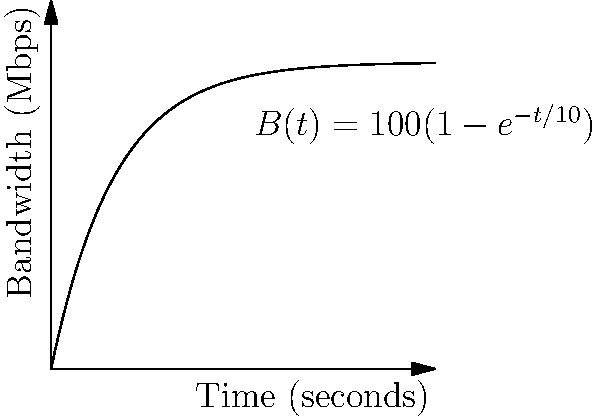Given the network bandwidth curve $B(t) = 100(1-e^{-t/10})$ Mbps, where $t$ is time in seconds, determine the optimal time to transfer a 500 MB file to maximize the average transfer rate. Round your answer to the nearest second. To find the optimal time, we need to maximize the average transfer rate. Let's approach this step-by-step:

1) The total data transferred up to time $t$ is the integral of $B(t)$ from 0 to $t$:

   $D(t) = \int_0^t B(t) dt = \int_0^t 100(1-e^{-t/10}) dt = 100t + 1000e^{-t/10} - 1000$

2) The average transfer rate $R(t)$ is the total data transferred divided by time:

   $R(t) = \frac{D(t)}{t} = 100 + \frac{1000}{t}(e^{-t/10} - 1)$

3) To find the maximum, we differentiate $R(t)$ and set it to zero:

   $R'(t) = \frac{1000}{t^2}(1 - e^{-t/10}(1 + \frac{t}{10})) = 0$

4) This equation can't be solved analytically. We need to use numerical methods.

5) Using a computer algebra system or numerical approximation, we find that $R(t)$ reaches its maximum at approximately $t \approx 21.62$ seconds.

6) However, we need to transfer 500 MB = 4000 Mb. Let's check if this is enough time:

   $D(21.62) \approx 1628$ Mb, which is not enough.

7) Therefore, we need to find the time when $D(t) = 4000$ Mb. Using numerical methods again, we find $t \approx 46.05$ seconds.

8) Rounding to the nearest second, our answer is 46 seconds.
Answer: 46 seconds 